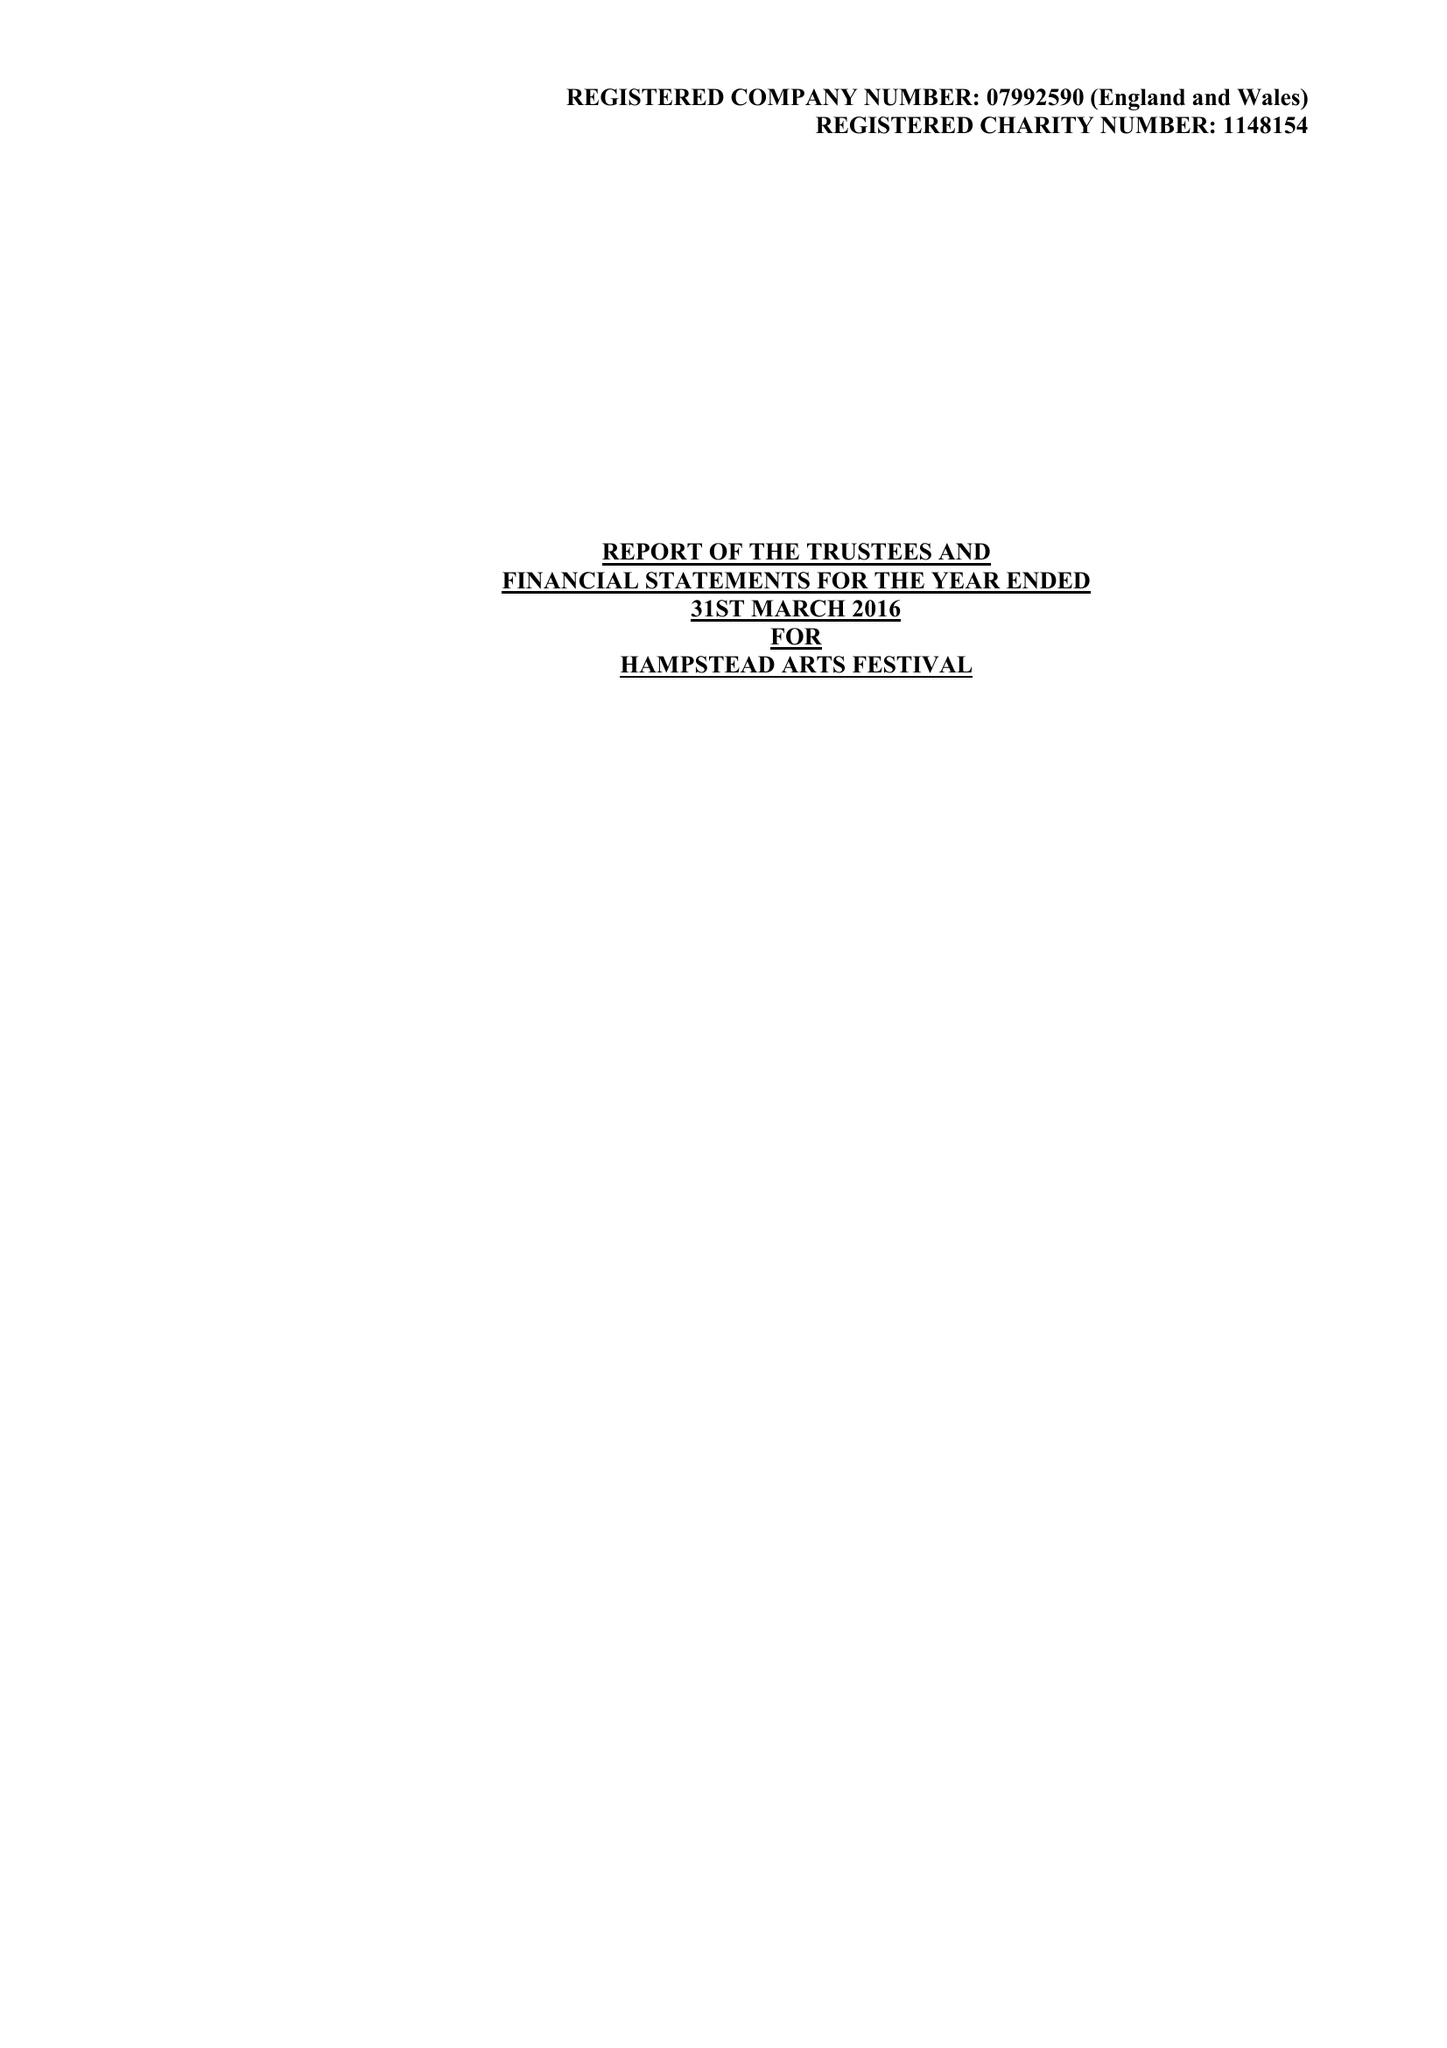What is the value for the charity_number?
Answer the question using a single word or phrase. 1148154 